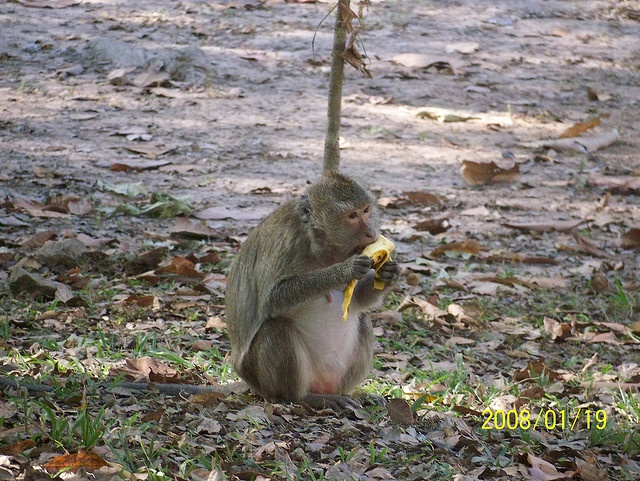Describe the objects in this image and their specific colors. I can see a banana in gray, beige, tan, and black tones in this image. 